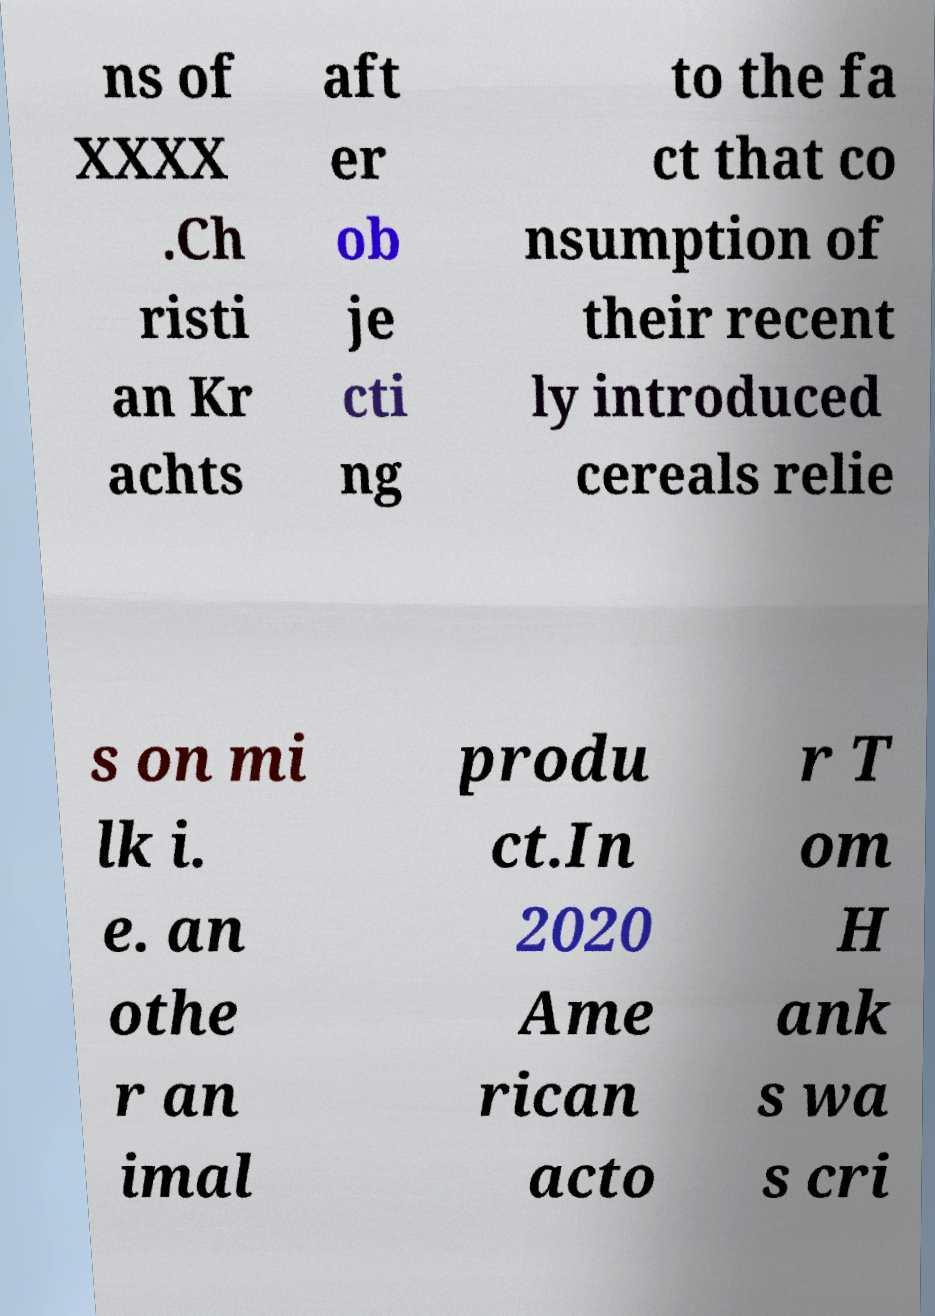Can you accurately transcribe the text from the provided image for me? ns of XXXX .Ch risti an Kr achts aft er ob je cti ng to the fa ct that co nsumption of their recent ly introduced cereals relie s on mi lk i. e. an othe r an imal produ ct.In 2020 Ame rican acto r T om H ank s wa s cri 